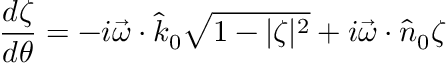Convert formula to latex. <formula><loc_0><loc_0><loc_500><loc_500>\frac { d \zeta } { d \theta } = - i \vec { \omega } \cdot \hat { k } _ { 0 } \sqrt { 1 - | \zeta | ^ { 2 } } + i \vec { \omega } \cdot \hat { n } _ { 0 } \zeta</formula> 